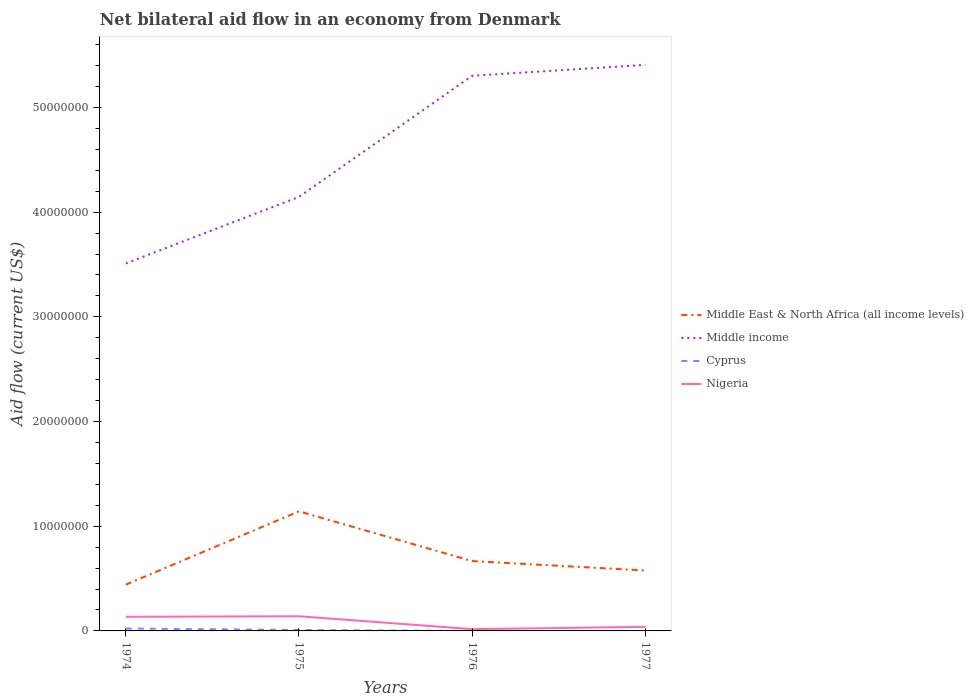How many different coloured lines are there?
Keep it short and to the point. 4. Does the line corresponding to Middle East & North Africa (all income levels) intersect with the line corresponding to Nigeria?
Give a very brief answer. No. Is the number of lines equal to the number of legend labels?
Give a very brief answer. No. What is the total net bilateral aid flow in Middle East & North Africa (all income levels) in the graph?
Give a very brief answer. -2.25e+06. What is the difference between the highest and the second highest net bilateral aid flow in Middle East & North Africa (all income levels)?
Keep it short and to the point. 7.00e+06. What is the difference between the highest and the lowest net bilateral aid flow in Cyprus?
Provide a short and direct response. 2. Is the net bilateral aid flow in Nigeria strictly greater than the net bilateral aid flow in Cyprus over the years?
Offer a very short reply. No. How many lines are there?
Offer a terse response. 4. What is the difference between two consecutive major ticks on the Y-axis?
Offer a terse response. 1.00e+07. Does the graph contain any zero values?
Your answer should be compact. Yes. Where does the legend appear in the graph?
Keep it short and to the point. Center right. How many legend labels are there?
Make the answer very short. 4. What is the title of the graph?
Offer a very short reply. Net bilateral aid flow in an economy from Denmark. What is the label or title of the Y-axis?
Provide a succinct answer. Aid flow (current US$). What is the Aid flow (current US$) of Middle East & North Africa (all income levels) in 1974?
Your response must be concise. 4.42e+06. What is the Aid flow (current US$) in Middle income in 1974?
Keep it short and to the point. 3.51e+07. What is the Aid flow (current US$) in Cyprus in 1974?
Give a very brief answer. 2.30e+05. What is the Aid flow (current US$) in Nigeria in 1974?
Provide a succinct answer. 1.35e+06. What is the Aid flow (current US$) in Middle East & North Africa (all income levels) in 1975?
Your response must be concise. 1.14e+07. What is the Aid flow (current US$) of Middle income in 1975?
Provide a short and direct response. 4.15e+07. What is the Aid flow (current US$) of Cyprus in 1975?
Offer a very short reply. 9.00e+04. What is the Aid flow (current US$) of Nigeria in 1975?
Offer a terse response. 1.40e+06. What is the Aid flow (current US$) of Middle East & North Africa (all income levels) in 1976?
Your response must be concise. 6.67e+06. What is the Aid flow (current US$) of Middle income in 1976?
Provide a short and direct response. 5.30e+07. What is the Aid flow (current US$) in Cyprus in 1976?
Your answer should be compact. 0. What is the Aid flow (current US$) in Middle East & North Africa (all income levels) in 1977?
Give a very brief answer. 5.77e+06. What is the Aid flow (current US$) of Middle income in 1977?
Give a very brief answer. 5.41e+07. What is the Aid flow (current US$) in Cyprus in 1977?
Your answer should be very brief. 0. Across all years, what is the maximum Aid flow (current US$) of Middle East & North Africa (all income levels)?
Give a very brief answer. 1.14e+07. Across all years, what is the maximum Aid flow (current US$) in Middle income?
Keep it short and to the point. 5.41e+07. Across all years, what is the maximum Aid flow (current US$) in Nigeria?
Keep it short and to the point. 1.40e+06. Across all years, what is the minimum Aid flow (current US$) in Middle East & North Africa (all income levels)?
Keep it short and to the point. 4.42e+06. Across all years, what is the minimum Aid flow (current US$) of Middle income?
Ensure brevity in your answer.  3.51e+07. Across all years, what is the minimum Aid flow (current US$) of Cyprus?
Your answer should be very brief. 0. Across all years, what is the minimum Aid flow (current US$) in Nigeria?
Offer a terse response. 1.70e+05. What is the total Aid flow (current US$) in Middle East & North Africa (all income levels) in the graph?
Give a very brief answer. 2.83e+07. What is the total Aid flow (current US$) in Middle income in the graph?
Provide a short and direct response. 1.84e+08. What is the total Aid flow (current US$) in Nigeria in the graph?
Your response must be concise. 3.31e+06. What is the difference between the Aid flow (current US$) in Middle East & North Africa (all income levels) in 1974 and that in 1975?
Your answer should be very brief. -7.00e+06. What is the difference between the Aid flow (current US$) in Middle income in 1974 and that in 1975?
Provide a short and direct response. -6.36e+06. What is the difference between the Aid flow (current US$) in Cyprus in 1974 and that in 1975?
Your answer should be compact. 1.40e+05. What is the difference between the Aid flow (current US$) in Middle East & North Africa (all income levels) in 1974 and that in 1976?
Your answer should be very brief. -2.25e+06. What is the difference between the Aid flow (current US$) of Middle income in 1974 and that in 1976?
Make the answer very short. -1.79e+07. What is the difference between the Aid flow (current US$) in Nigeria in 1974 and that in 1976?
Offer a very short reply. 1.18e+06. What is the difference between the Aid flow (current US$) in Middle East & North Africa (all income levels) in 1974 and that in 1977?
Offer a terse response. -1.35e+06. What is the difference between the Aid flow (current US$) of Middle income in 1974 and that in 1977?
Offer a terse response. -1.90e+07. What is the difference between the Aid flow (current US$) of Nigeria in 1974 and that in 1977?
Your response must be concise. 9.60e+05. What is the difference between the Aid flow (current US$) in Middle East & North Africa (all income levels) in 1975 and that in 1976?
Keep it short and to the point. 4.75e+06. What is the difference between the Aid flow (current US$) in Middle income in 1975 and that in 1976?
Offer a very short reply. -1.16e+07. What is the difference between the Aid flow (current US$) of Nigeria in 1975 and that in 1976?
Ensure brevity in your answer.  1.23e+06. What is the difference between the Aid flow (current US$) of Middle East & North Africa (all income levels) in 1975 and that in 1977?
Your response must be concise. 5.65e+06. What is the difference between the Aid flow (current US$) in Middle income in 1975 and that in 1977?
Give a very brief answer. -1.26e+07. What is the difference between the Aid flow (current US$) of Nigeria in 1975 and that in 1977?
Make the answer very short. 1.01e+06. What is the difference between the Aid flow (current US$) of Middle income in 1976 and that in 1977?
Make the answer very short. -1.04e+06. What is the difference between the Aid flow (current US$) in Middle East & North Africa (all income levels) in 1974 and the Aid flow (current US$) in Middle income in 1975?
Offer a terse response. -3.70e+07. What is the difference between the Aid flow (current US$) of Middle East & North Africa (all income levels) in 1974 and the Aid flow (current US$) of Cyprus in 1975?
Offer a very short reply. 4.33e+06. What is the difference between the Aid flow (current US$) of Middle East & North Africa (all income levels) in 1974 and the Aid flow (current US$) of Nigeria in 1975?
Give a very brief answer. 3.02e+06. What is the difference between the Aid flow (current US$) of Middle income in 1974 and the Aid flow (current US$) of Cyprus in 1975?
Ensure brevity in your answer.  3.50e+07. What is the difference between the Aid flow (current US$) of Middle income in 1974 and the Aid flow (current US$) of Nigeria in 1975?
Provide a short and direct response. 3.37e+07. What is the difference between the Aid flow (current US$) of Cyprus in 1974 and the Aid flow (current US$) of Nigeria in 1975?
Give a very brief answer. -1.17e+06. What is the difference between the Aid flow (current US$) of Middle East & North Africa (all income levels) in 1974 and the Aid flow (current US$) of Middle income in 1976?
Ensure brevity in your answer.  -4.86e+07. What is the difference between the Aid flow (current US$) in Middle East & North Africa (all income levels) in 1974 and the Aid flow (current US$) in Nigeria in 1976?
Your answer should be very brief. 4.25e+06. What is the difference between the Aid flow (current US$) of Middle income in 1974 and the Aid flow (current US$) of Nigeria in 1976?
Your response must be concise. 3.49e+07. What is the difference between the Aid flow (current US$) of Cyprus in 1974 and the Aid flow (current US$) of Nigeria in 1976?
Provide a short and direct response. 6.00e+04. What is the difference between the Aid flow (current US$) of Middle East & North Africa (all income levels) in 1974 and the Aid flow (current US$) of Middle income in 1977?
Make the answer very short. -4.96e+07. What is the difference between the Aid flow (current US$) in Middle East & North Africa (all income levels) in 1974 and the Aid flow (current US$) in Nigeria in 1977?
Offer a terse response. 4.03e+06. What is the difference between the Aid flow (current US$) of Middle income in 1974 and the Aid flow (current US$) of Nigeria in 1977?
Offer a terse response. 3.47e+07. What is the difference between the Aid flow (current US$) of Cyprus in 1974 and the Aid flow (current US$) of Nigeria in 1977?
Offer a terse response. -1.60e+05. What is the difference between the Aid flow (current US$) in Middle East & North Africa (all income levels) in 1975 and the Aid flow (current US$) in Middle income in 1976?
Make the answer very short. -4.16e+07. What is the difference between the Aid flow (current US$) of Middle East & North Africa (all income levels) in 1975 and the Aid flow (current US$) of Nigeria in 1976?
Your answer should be compact. 1.12e+07. What is the difference between the Aid flow (current US$) in Middle income in 1975 and the Aid flow (current US$) in Nigeria in 1976?
Your answer should be very brief. 4.13e+07. What is the difference between the Aid flow (current US$) in Middle East & North Africa (all income levels) in 1975 and the Aid flow (current US$) in Middle income in 1977?
Keep it short and to the point. -4.26e+07. What is the difference between the Aid flow (current US$) in Middle East & North Africa (all income levels) in 1975 and the Aid flow (current US$) in Nigeria in 1977?
Ensure brevity in your answer.  1.10e+07. What is the difference between the Aid flow (current US$) in Middle income in 1975 and the Aid flow (current US$) in Nigeria in 1977?
Your response must be concise. 4.11e+07. What is the difference between the Aid flow (current US$) in Middle East & North Africa (all income levels) in 1976 and the Aid flow (current US$) in Middle income in 1977?
Offer a terse response. -4.74e+07. What is the difference between the Aid flow (current US$) in Middle East & North Africa (all income levels) in 1976 and the Aid flow (current US$) in Nigeria in 1977?
Provide a short and direct response. 6.28e+06. What is the difference between the Aid flow (current US$) in Middle income in 1976 and the Aid flow (current US$) in Nigeria in 1977?
Your answer should be very brief. 5.26e+07. What is the average Aid flow (current US$) of Middle East & North Africa (all income levels) per year?
Ensure brevity in your answer.  7.07e+06. What is the average Aid flow (current US$) in Middle income per year?
Provide a succinct answer. 4.59e+07. What is the average Aid flow (current US$) in Nigeria per year?
Provide a short and direct response. 8.28e+05. In the year 1974, what is the difference between the Aid flow (current US$) in Middle East & North Africa (all income levels) and Aid flow (current US$) in Middle income?
Your answer should be very brief. -3.07e+07. In the year 1974, what is the difference between the Aid flow (current US$) in Middle East & North Africa (all income levels) and Aid flow (current US$) in Cyprus?
Your answer should be compact. 4.19e+06. In the year 1974, what is the difference between the Aid flow (current US$) in Middle East & North Africa (all income levels) and Aid flow (current US$) in Nigeria?
Your answer should be very brief. 3.07e+06. In the year 1974, what is the difference between the Aid flow (current US$) of Middle income and Aid flow (current US$) of Cyprus?
Ensure brevity in your answer.  3.49e+07. In the year 1974, what is the difference between the Aid flow (current US$) in Middle income and Aid flow (current US$) in Nigeria?
Your answer should be very brief. 3.38e+07. In the year 1974, what is the difference between the Aid flow (current US$) of Cyprus and Aid flow (current US$) of Nigeria?
Ensure brevity in your answer.  -1.12e+06. In the year 1975, what is the difference between the Aid flow (current US$) of Middle East & North Africa (all income levels) and Aid flow (current US$) of Middle income?
Provide a short and direct response. -3.00e+07. In the year 1975, what is the difference between the Aid flow (current US$) in Middle East & North Africa (all income levels) and Aid flow (current US$) in Cyprus?
Provide a short and direct response. 1.13e+07. In the year 1975, what is the difference between the Aid flow (current US$) of Middle East & North Africa (all income levels) and Aid flow (current US$) of Nigeria?
Your answer should be compact. 1.00e+07. In the year 1975, what is the difference between the Aid flow (current US$) in Middle income and Aid flow (current US$) in Cyprus?
Ensure brevity in your answer.  4.14e+07. In the year 1975, what is the difference between the Aid flow (current US$) in Middle income and Aid flow (current US$) in Nigeria?
Your answer should be very brief. 4.01e+07. In the year 1975, what is the difference between the Aid flow (current US$) of Cyprus and Aid flow (current US$) of Nigeria?
Keep it short and to the point. -1.31e+06. In the year 1976, what is the difference between the Aid flow (current US$) in Middle East & North Africa (all income levels) and Aid flow (current US$) in Middle income?
Make the answer very short. -4.64e+07. In the year 1976, what is the difference between the Aid flow (current US$) of Middle East & North Africa (all income levels) and Aid flow (current US$) of Nigeria?
Your response must be concise. 6.50e+06. In the year 1976, what is the difference between the Aid flow (current US$) of Middle income and Aid flow (current US$) of Nigeria?
Provide a succinct answer. 5.29e+07. In the year 1977, what is the difference between the Aid flow (current US$) of Middle East & North Africa (all income levels) and Aid flow (current US$) of Middle income?
Provide a short and direct response. -4.83e+07. In the year 1977, what is the difference between the Aid flow (current US$) in Middle East & North Africa (all income levels) and Aid flow (current US$) in Nigeria?
Your answer should be compact. 5.38e+06. In the year 1977, what is the difference between the Aid flow (current US$) of Middle income and Aid flow (current US$) of Nigeria?
Offer a terse response. 5.37e+07. What is the ratio of the Aid flow (current US$) in Middle East & North Africa (all income levels) in 1974 to that in 1975?
Offer a very short reply. 0.39. What is the ratio of the Aid flow (current US$) in Middle income in 1974 to that in 1975?
Ensure brevity in your answer.  0.85. What is the ratio of the Aid flow (current US$) in Cyprus in 1974 to that in 1975?
Your response must be concise. 2.56. What is the ratio of the Aid flow (current US$) of Nigeria in 1974 to that in 1975?
Provide a short and direct response. 0.96. What is the ratio of the Aid flow (current US$) in Middle East & North Africa (all income levels) in 1974 to that in 1976?
Ensure brevity in your answer.  0.66. What is the ratio of the Aid flow (current US$) in Middle income in 1974 to that in 1976?
Ensure brevity in your answer.  0.66. What is the ratio of the Aid flow (current US$) of Nigeria in 1974 to that in 1976?
Keep it short and to the point. 7.94. What is the ratio of the Aid flow (current US$) of Middle East & North Africa (all income levels) in 1974 to that in 1977?
Your response must be concise. 0.77. What is the ratio of the Aid flow (current US$) in Middle income in 1974 to that in 1977?
Offer a very short reply. 0.65. What is the ratio of the Aid flow (current US$) in Nigeria in 1974 to that in 1977?
Offer a very short reply. 3.46. What is the ratio of the Aid flow (current US$) in Middle East & North Africa (all income levels) in 1975 to that in 1976?
Give a very brief answer. 1.71. What is the ratio of the Aid flow (current US$) in Middle income in 1975 to that in 1976?
Make the answer very short. 0.78. What is the ratio of the Aid flow (current US$) in Nigeria in 1975 to that in 1976?
Offer a terse response. 8.24. What is the ratio of the Aid flow (current US$) of Middle East & North Africa (all income levels) in 1975 to that in 1977?
Offer a terse response. 1.98. What is the ratio of the Aid flow (current US$) in Middle income in 1975 to that in 1977?
Make the answer very short. 0.77. What is the ratio of the Aid flow (current US$) in Nigeria in 1975 to that in 1977?
Offer a very short reply. 3.59. What is the ratio of the Aid flow (current US$) of Middle East & North Africa (all income levels) in 1976 to that in 1977?
Your response must be concise. 1.16. What is the ratio of the Aid flow (current US$) of Middle income in 1976 to that in 1977?
Make the answer very short. 0.98. What is the ratio of the Aid flow (current US$) of Nigeria in 1976 to that in 1977?
Provide a succinct answer. 0.44. What is the difference between the highest and the second highest Aid flow (current US$) in Middle East & North Africa (all income levels)?
Offer a terse response. 4.75e+06. What is the difference between the highest and the second highest Aid flow (current US$) in Middle income?
Make the answer very short. 1.04e+06. What is the difference between the highest and the second highest Aid flow (current US$) in Nigeria?
Offer a terse response. 5.00e+04. What is the difference between the highest and the lowest Aid flow (current US$) of Middle income?
Offer a terse response. 1.90e+07. What is the difference between the highest and the lowest Aid flow (current US$) of Cyprus?
Offer a terse response. 2.30e+05. What is the difference between the highest and the lowest Aid flow (current US$) of Nigeria?
Give a very brief answer. 1.23e+06. 